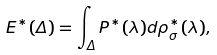Convert formula to latex. <formula><loc_0><loc_0><loc_500><loc_500>E ^ { \ast } ( \Delta ) = \int _ { \Delta } P ^ { \ast } ( \lambda ) d \rho _ { \sigma } ^ { \ast } ( \lambda ) ,</formula> 